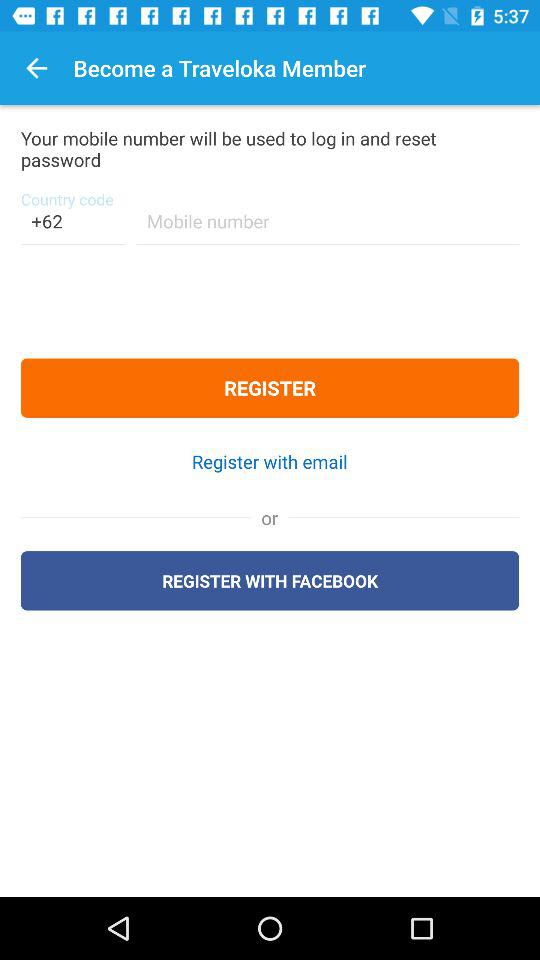What application can be used to register? You can use Facebook to register. 